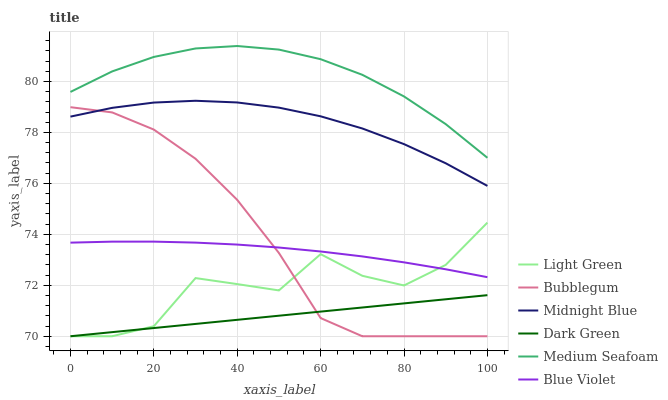Does Dark Green have the minimum area under the curve?
Answer yes or no. Yes. Does Medium Seafoam have the maximum area under the curve?
Answer yes or no. Yes. Does Bubblegum have the minimum area under the curve?
Answer yes or no. No. Does Bubblegum have the maximum area under the curve?
Answer yes or no. No. Is Dark Green the smoothest?
Answer yes or no. Yes. Is Light Green the roughest?
Answer yes or no. Yes. Is Bubblegum the smoothest?
Answer yes or no. No. Is Bubblegum the roughest?
Answer yes or no. No. Does Bubblegum have the lowest value?
Answer yes or no. Yes. Does Medium Seafoam have the lowest value?
Answer yes or no. No. Does Medium Seafoam have the highest value?
Answer yes or no. Yes. Does Bubblegum have the highest value?
Answer yes or no. No. Is Midnight Blue less than Medium Seafoam?
Answer yes or no. Yes. Is Medium Seafoam greater than Light Green?
Answer yes or no. Yes. Does Bubblegum intersect Dark Green?
Answer yes or no. Yes. Is Bubblegum less than Dark Green?
Answer yes or no. No. Is Bubblegum greater than Dark Green?
Answer yes or no. No. Does Midnight Blue intersect Medium Seafoam?
Answer yes or no. No. 